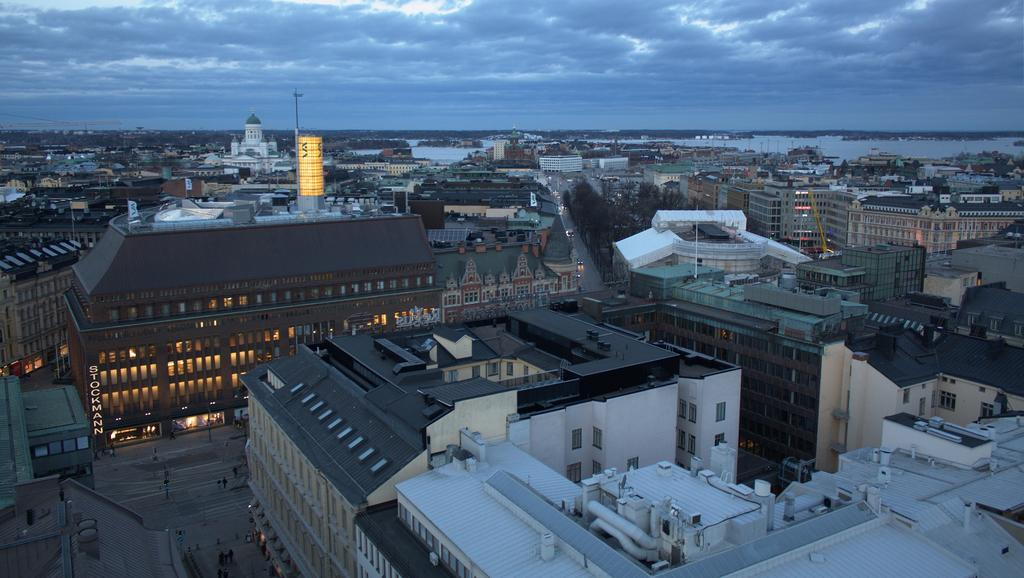What type of view is shown in the image? The image is a top view of a city. What kind of structures can be seen in the city? There are many huge buildings in the image. Are there any residential areas in the image? Yes, there are houses in the image. What natural element is visible in the background of the image? There is a water surface visible in the background of the image. Where can the flowers be seen in the image? There are no flowers visible in the image. Can you tell me how many bats are flying over the city in the image? There are no bats present in the image. 